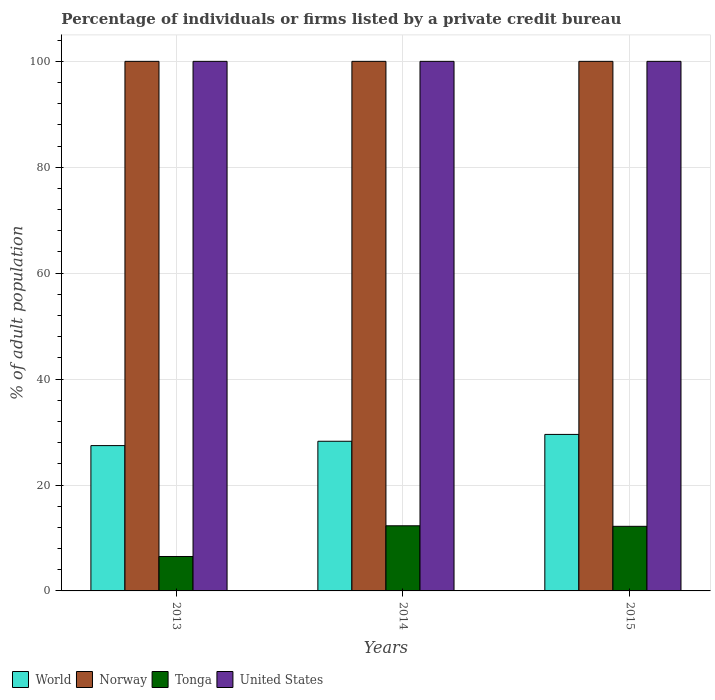How many groups of bars are there?
Keep it short and to the point. 3. Are the number of bars on each tick of the X-axis equal?
Provide a succinct answer. Yes. How many bars are there on the 2nd tick from the left?
Your answer should be very brief. 4. How many bars are there on the 2nd tick from the right?
Ensure brevity in your answer.  4. Across all years, what is the minimum percentage of population listed by a private credit bureau in United States?
Your answer should be compact. 100. In which year was the percentage of population listed by a private credit bureau in Tonga minimum?
Your response must be concise. 2013. What is the total percentage of population listed by a private credit bureau in Norway in the graph?
Make the answer very short. 300. What is the difference between the percentage of population listed by a private credit bureau in United States in 2013 and that in 2015?
Make the answer very short. 0. What is the difference between the percentage of population listed by a private credit bureau in World in 2015 and the percentage of population listed by a private credit bureau in Norway in 2013?
Keep it short and to the point. -70.45. In the year 2013, what is the difference between the percentage of population listed by a private credit bureau in Tonga and percentage of population listed by a private credit bureau in United States?
Offer a terse response. -93.5. In how many years, is the percentage of population listed by a private credit bureau in Tonga greater than 24 %?
Your response must be concise. 0. What is the ratio of the percentage of population listed by a private credit bureau in Tonga in 2013 to that in 2014?
Give a very brief answer. 0.53. Is the percentage of population listed by a private credit bureau in World in 2013 less than that in 2015?
Make the answer very short. Yes. What is the difference between the highest and the second highest percentage of population listed by a private credit bureau in Norway?
Ensure brevity in your answer.  0. What is the difference between the highest and the lowest percentage of population listed by a private credit bureau in United States?
Provide a succinct answer. 0. In how many years, is the percentage of population listed by a private credit bureau in World greater than the average percentage of population listed by a private credit bureau in World taken over all years?
Offer a very short reply. 1. Is the sum of the percentage of population listed by a private credit bureau in Norway in 2013 and 2015 greater than the maximum percentage of population listed by a private credit bureau in United States across all years?
Keep it short and to the point. Yes. Is it the case that in every year, the sum of the percentage of population listed by a private credit bureau in Tonga and percentage of population listed by a private credit bureau in World is greater than the sum of percentage of population listed by a private credit bureau in Norway and percentage of population listed by a private credit bureau in United States?
Make the answer very short. No. What does the 4th bar from the left in 2015 represents?
Provide a short and direct response. United States. How many bars are there?
Your answer should be compact. 12. Are the values on the major ticks of Y-axis written in scientific E-notation?
Your response must be concise. No. Does the graph contain any zero values?
Ensure brevity in your answer.  No. Where does the legend appear in the graph?
Your response must be concise. Bottom left. How many legend labels are there?
Give a very brief answer. 4. How are the legend labels stacked?
Offer a very short reply. Horizontal. What is the title of the graph?
Your answer should be compact. Percentage of individuals or firms listed by a private credit bureau. What is the label or title of the X-axis?
Provide a short and direct response. Years. What is the label or title of the Y-axis?
Ensure brevity in your answer.  % of adult population. What is the % of adult population of World in 2013?
Your response must be concise. 27.44. What is the % of adult population in Norway in 2013?
Give a very brief answer. 100. What is the % of adult population in Tonga in 2013?
Keep it short and to the point. 6.5. What is the % of adult population in United States in 2013?
Provide a short and direct response. 100. What is the % of adult population in World in 2014?
Ensure brevity in your answer.  28.26. What is the % of adult population in Tonga in 2014?
Offer a very short reply. 12.3. What is the % of adult population of World in 2015?
Ensure brevity in your answer.  29.55. What is the % of adult population in Tonga in 2015?
Make the answer very short. 12.2. Across all years, what is the maximum % of adult population of World?
Your answer should be compact. 29.55. Across all years, what is the minimum % of adult population in World?
Give a very brief answer. 27.44. Across all years, what is the minimum % of adult population in Norway?
Provide a succinct answer. 100. Across all years, what is the minimum % of adult population of Tonga?
Ensure brevity in your answer.  6.5. What is the total % of adult population of World in the graph?
Give a very brief answer. 85.26. What is the total % of adult population of Norway in the graph?
Your answer should be compact. 300. What is the total % of adult population of United States in the graph?
Provide a short and direct response. 300. What is the difference between the % of adult population in World in 2013 and that in 2014?
Ensure brevity in your answer.  -0.82. What is the difference between the % of adult population in Norway in 2013 and that in 2014?
Your response must be concise. 0. What is the difference between the % of adult population of United States in 2013 and that in 2014?
Keep it short and to the point. 0. What is the difference between the % of adult population in World in 2013 and that in 2015?
Keep it short and to the point. -2.11. What is the difference between the % of adult population of Norway in 2013 and that in 2015?
Keep it short and to the point. 0. What is the difference between the % of adult population of Tonga in 2013 and that in 2015?
Your response must be concise. -5.7. What is the difference between the % of adult population in World in 2014 and that in 2015?
Offer a very short reply. -1.29. What is the difference between the % of adult population of World in 2013 and the % of adult population of Norway in 2014?
Provide a succinct answer. -72.56. What is the difference between the % of adult population of World in 2013 and the % of adult population of Tonga in 2014?
Make the answer very short. 15.14. What is the difference between the % of adult population of World in 2013 and the % of adult population of United States in 2014?
Offer a terse response. -72.56. What is the difference between the % of adult population in Norway in 2013 and the % of adult population in Tonga in 2014?
Provide a short and direct response. 87.7. What is the difference between the % of adult population of Tonga in 2013 and the % of adult population of United States in 2014?
Provide a short and direct response. -93.5. What is the difference between the % of adult population of World in 2013 and the % of adult population of Norway in 2015?
Make the answer very short. -72.56. What is the difference between the % of adult population of World in 2013 and the % of adult population of Tonga in 2015?
Your response must be concise. 15.24. What is the difference between the % of adult population of World in 2013 and the % of adult population of United States in 2015?
Your response must be concise. -72.56. What is the difference between the % of adult population of Norway in 2013 and the % of adult population of Tonga in 2015?
Offer a very short reply. 87.8. What is the difference between the % of adult population in Tonga in 2013 and the % of adult population in United States in 2015?
Offer a terse response. -93.5. What is the difference between the % of adult population of World in 2014 and the % of adult population of Norway in 2015?
Provide a succinct answer. -71.74. What is the difference between the % of adult population in World in 2014 and the % of adult population in Tonga in 2015?
Offer a very short reply. 16.06. What is the difference between the % of adult population in World in 2014 and the % of adult population in United States in 2015?
Provide a short and direct response. -71.74. What is the difference between the % of adult population in Norway in 2014 and the % of adult population in Tonga in 2015?
Offer a terse response. 87.8. What is the difference between the % of adult population of Tonga in 2014 and the % of adult population of United States in 2015?
Your answer should be compact. -87.7. What is the average % of adult population of World per year?
Your response must be concise. 28.42. What is the average % of adult population in Norway per year?
Your answer should be very brief. 100. What is the average % of adult population in Tonga per year?
Give a very brief answer. 10.33. In the year 2013, what is the difference between the % of adult population in World and % of adult population in Norway?
Provide a short and direct response. -72.56. In the year 2013, what is the difference between the % of adult population in World and % of adult population in Tonga?
Your response must be concise. 20.94. In the year 2013, what is the difference between the % of adult population in World and % of adult population in United States?
Make the answer very short. -72.56. In the year 2013, what is the difference between the % of adult population of Norway and % of adult population of Tonga?
Provide a succinct answer. 93.5. In the year 2013, what is the difference between the % of adult population in Norway and % of adult population in United States?
Make the answer very short. 0. In the year 2013, what is the difference between the % of adult population of Tonga and % of adult population of United States?
Your answer should be compact. -93.5. In the year 2014, what is the difference between the % of adult population in World and % of adult population in Norway?
Keep it short and to the point. -71.74. In the year 2014, what is the difference between the % of adult population in World and % of adult population in Tonga?
Provide a short and direct response. 15.96. In the year 2014, what is the difference between the % of adult population of World and % of adult population of United States?
Offer a very short reply. -71.74. In the year 2014, what is the difference between the % of adult population of Norway and % of adult population of Tonga?
Offer a very short reply. 87.7. In the year 2014, what is the difference between the % of adult population of Tonga and % of adult population of United States?
Provide a succinct answer. -87.7. In the year 2015, what is the difference between the % of adult population in World and % of adult population in Norway?
Give a very brief answer. -70.45. In the year 2015, what is the difference between the % of adult population of World and % of adult population of Tonga?
Provide a short and direct response. 17.35. In the year 2015, what is the difference between the % of adult population in World and % of adult population in United States?
Provide a succinct answer. -70.45. In the year 2015, what is the difference between the % of adult population in Norway and % of adult population in Tonga?
Make the answer very short. 87.8. In the year 2015, what is the difference between the % of adult population of Tonga and % of adult population of United States?
Your answer should be very brief. -87.8. What is the ratio of the % of adult population in World in 2013 to that in 2014?
Offer a terse response. 0.97. What is the ratio of the % of adult population in Norway in 2013 to that in 2014?
Provide a succinct answer. 1. What is the ratio of the % of adult population of Tonga in 2013 to that in 2014?
Provide a short and direct response. 0.53. What is the ratio of the % of adult population in World in 2013 to that in 2015?
Give a very brief answer. 0.93. What is the ratio of the % of adult population of Norway in 2013 to that in 2015?
Keep it short and to the point. 1. What is the ratio of the % of adult population in Tonga in 2013 to that in 2015?
Offer a very short reply. 0.53. What is the ratio of the % of adult population of United States in 2013 to that in 2015?
Give a very brief answer. 1. What is the ratio of the % of adult population of World in 2014 to that in 2015?
Provide a succinct answer. 0.96. What is the ratio of the % of adult population in Tonga in 2014 to that in 2015?
Your response must be concise. 1.01. What is the difference between the highest and the second highest % of adult population of World?
Make the answer very short. 1.29. What is the difference between the highest and the second highest % of adult population of Tonga?
Provide a short and direct response. 0.1. What is the difference between the highest and the lowest % of adult population in World?
Provide a short and direct response. 2.11. What is the difference between the highest and the lowest % of adult population in Tonga?
Offer a terse response. 5.8. 